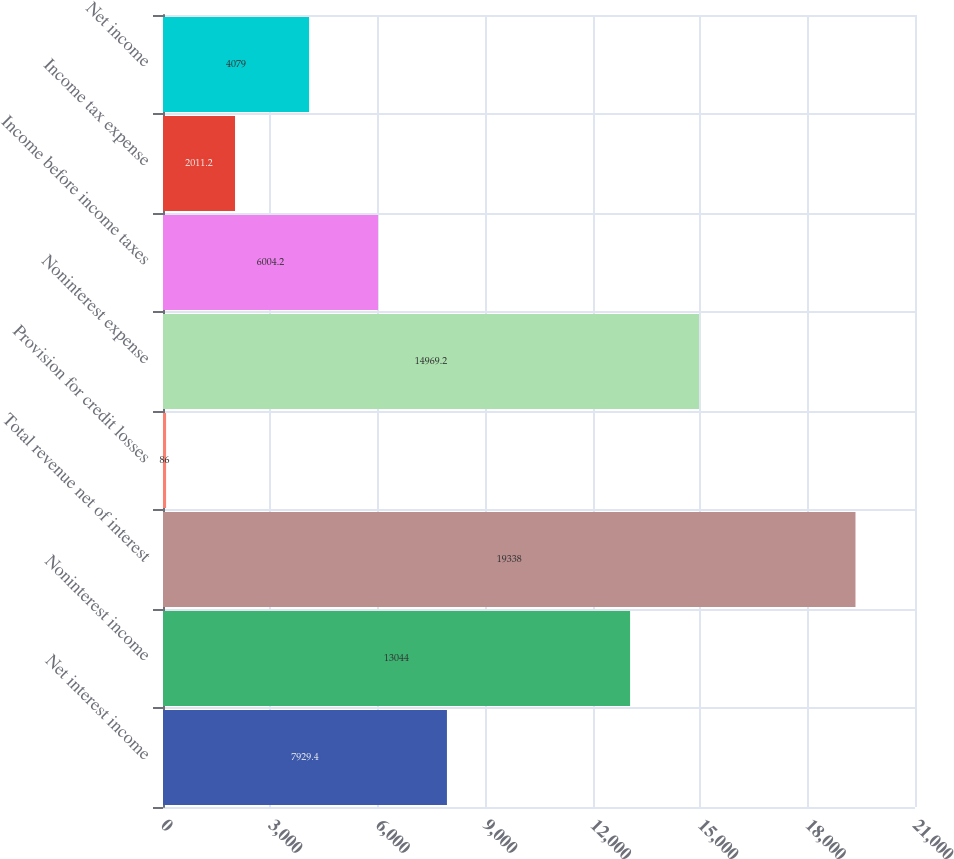Convert chart. <chart><loc_0><loc_0><loc_500><loc_500><bar_chart><fcel>Net interest income<fcel>Noninterest income<fcel>Total revenue net of interest<fcel>Provision for credit losses<fcel>Noninterest expense<fcel>Income before income taxes<fcel>Income tax expense<fcel>Net income<nl><fcel>7929.4<fcel>13044<fcel>19338<fcel>86<fcel>14969.2<fcel>6004.2<fcel>2011.2<fcel>4079<nl></chart> 